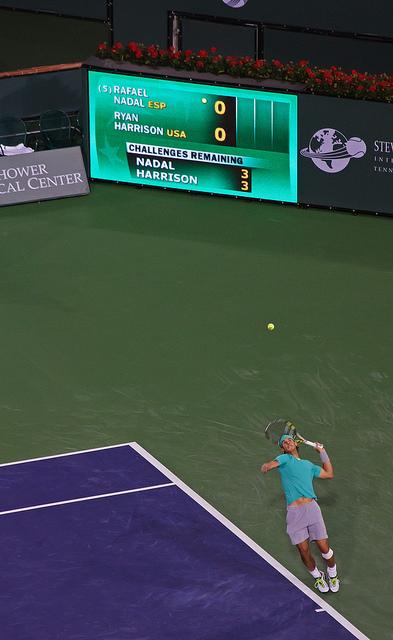What event is the man playing in?
Concise answer only. Tennis. What is in the picture?
Keep it brief. Tennis player. What color is the man's shirt?
Give a very brief answer. Blue. 